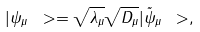<formula> <loc_0><loc_0><loc_500><loc_500>| \psi _ { \mu } \ > = \sqrt { \lambda _ { \mu } } \sqrt { D _ { \mu } } | \tilde { \psi } _ { \mu } \ > ,</formula> 